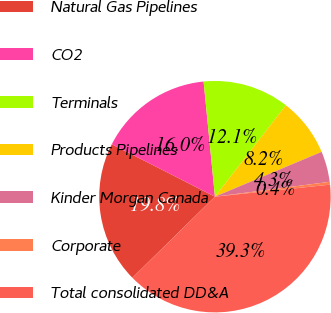Convert chart to OTSL. <chart><loc_0><loc_0><loc_500><loc_500><pie_chart><fcel>Natural Gas Pipelines<fcel>CO2<fcel>Terminals<fcel>Products Pipelines<fcel>Kinder Morgan Canada<fcel>Corporate<fcel>Total consolidated DD&A<nl><fcel>19.84%<fcel>15.95%<fcel>12.06%<fcel>8.17%<fcel>4.28%<fcel>0.39%<fcel>39.3%<nl></chart> 